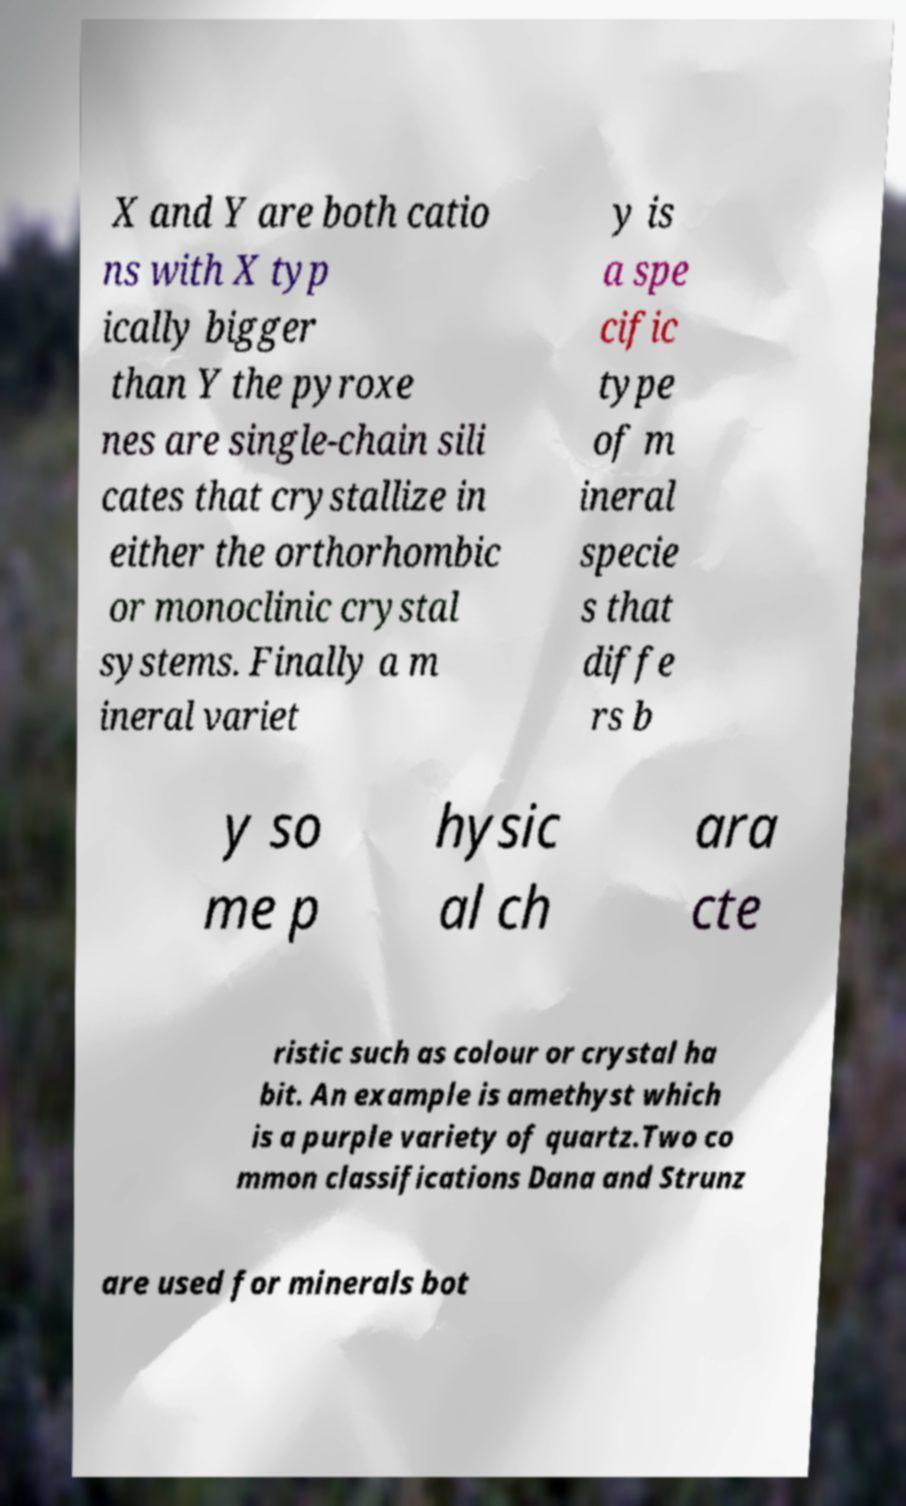Could you extract and type out the text from this image? X and Y are both catio ns with X typ ically bigger than Y the pyroxe nes are single-chain sili cates that crystallize in either the orthorhombic or monoclinic crystal systems. Finally a m ineral variet y is a spe cific type of m ineral specie s that diffe rs b y so me p hysic al ch ara cte ristic such as colour or crystal ha bit. An example is amethyst which is a purple variety of quartz.Two co mmon classifications Dana and Strunz are used for minerals bot 